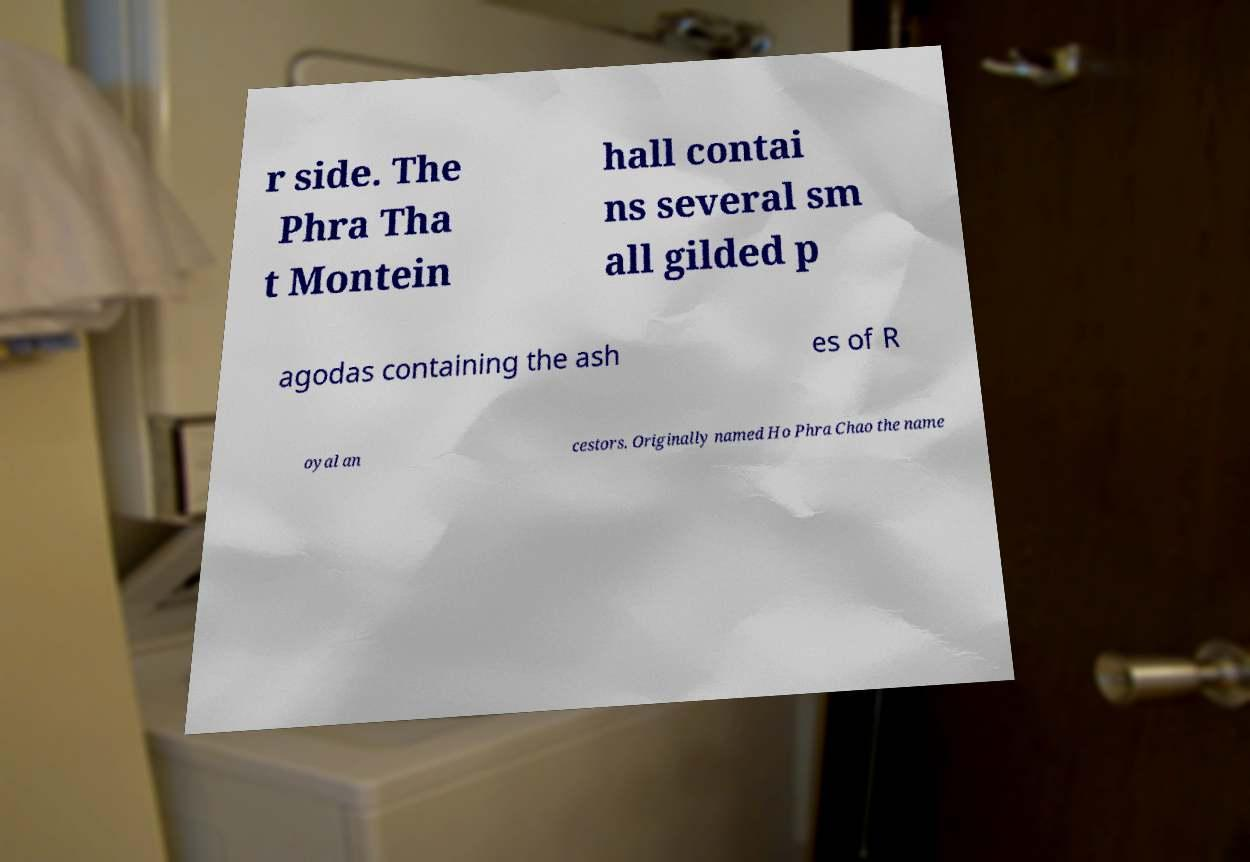Could you extract and type out the text from this image? r side. The Phra Tha t Montein hall contai ns several sm all gilded p agodas containing the ash es of R oyal an cestors. Originally named Ho Phra Chao the name 